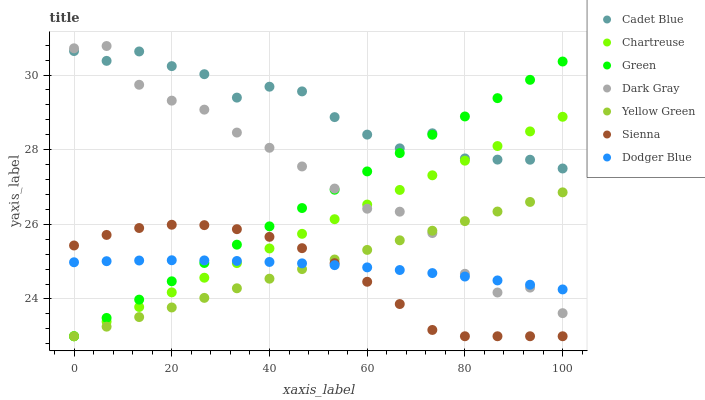Does Sienna have the minimum area under the curve?
Answer yes or no. Yes. Does Cadet Blue have the maximum area under the curve?
Answer yes or no. Yes. Does Yellow Green have the minimum area under the curve?
Answer yes or no. No. Does Yellow Green have the maximum area under the curve?
Answer yes or no. No. Is Green the smoothest?
Answer yes or no. Yes. Is Cadet Blue the roughest?
Answer yes or no. Yes. Is Yellow Green the smoothest?
Answer yes or no. No. Is Yellow Green the roughest?
Answer yes or no. No. Does Sienna have the lowest value?
Answer yes or no. Yes. Does Cadet Blue have the lowest value?
Answer yes or no. No. Does Dark Gray have the highest value?
Answer yes or no. Yes. Does Cadet Blue have the highest value?
Answer yes or no. No. Is Dodger Blue less than Cadet Blue?
Answer yes or no. Yes. Is Cadet Blue greater than Sienna?
Answer yes or no. Yes. Does Dodger Blue intersect Green?
Answer yes or no. Yes. Is Dodger Blue less than Green?
Answer yes or no. No. Is Dodger Blue greater than Green?
Answer yes or no. No. Does Dodger Blue intersect Cadet Blue?
Answer yes or no. No. 